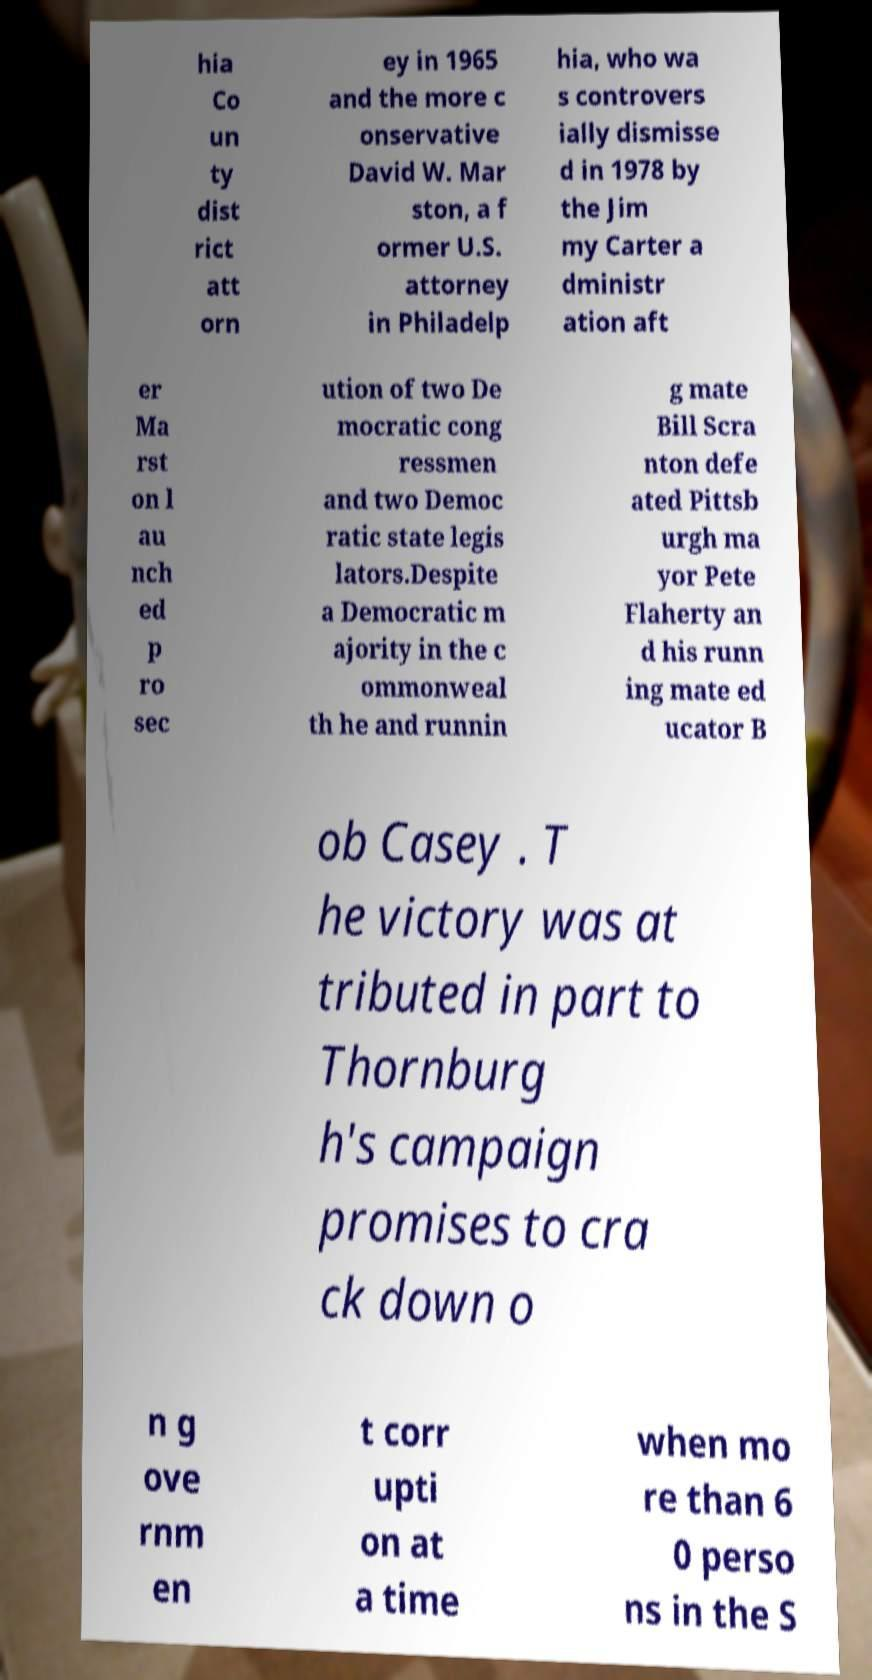I need the written content from this picture converted into text. Can you do that? hia Co un ty dist rict att orn ey in 1965 and the more c onservative David W. Mar ston, a f ormer U.S. attorney in Philadelp hia, who wa s controvers ially dismisse d in 1978 by the Jim my Carter a dministr ation aft er Ma rst on l au nch ed p ro sec ution of two De mocratic cong ressmen and two Democ ratic state legis lators.Despite a Democratic m ajority in the c ommonweal th he and runnin g mate Bill Scra nton defe ated Pittsb urgh ma yor Pete Flaherty an d his runn ing mate ed ucator B ob Casey . T he victory was at tributed in part to Thornburg h's campaign promises to cra ck down o n g ove rnm en t corr upti on at a time when mo re than 6 0 perso ns in the S 